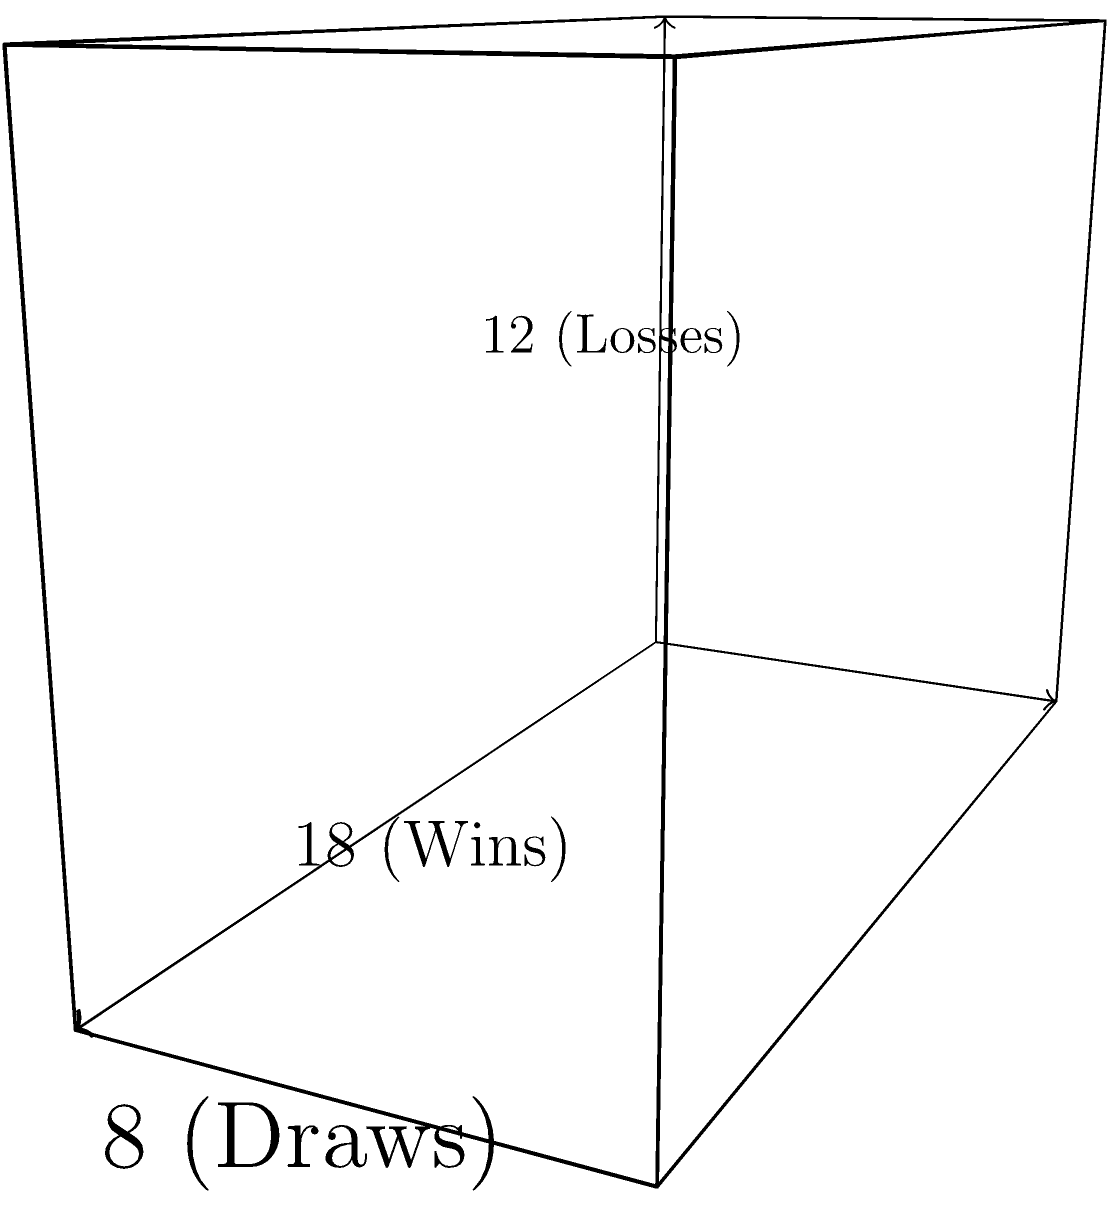SønderjyskE Herrehåndbold's performance last season can be represented by a rectangular prism. The length represents their 18 wins, the width their 8 draws, and the height their 12 losses. Calculate the volume of this prism, which symbolizes the team's overall season performance. What does this volume represent in the context of the team's season? To solve this problem, we need to follow these steps:

1) Recall the formula for the volume of a rectangular prism:
   $$ V = l \times w \times h $$
   where $V$ is volume, $l$ is length, $w$ is width, and $h$ is height.

2) Substitute the given values:
   $l = 18$ (wins)
   $w = 8$ (draws)
   $h = 12$ (losses)

3) Calculate the volume:
   $$ V = 18 \times 8 \times 12 $$
   $$ V = 144 \times 12 $$
   $$ V = 1,728 $$

4) Interpret the result:
   The volume of 1,728 represents the total number of possible game outcomes if every win, draw, and loss were to occur in all possible combinations. It's a theoretical maximum of scenarios based on the team's actual performance, not the actual number of games played.

This volume provides a single numerical representation of the team's season, combining wins, draws, and losses into one metric. A larger volume generally indicates more games played or a more varied performance across the season.
Answer: 1,728 (representing theoretical game outcome combinations) 